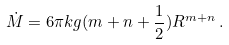Convert formula to latex. <formula><loc_0><loc_0><loc_500><loc_500>\dot { M } = 6 \pi k g ( m + n + \frac { 1 } { 2 } ) R ^ { m + n } \, .</formula> 